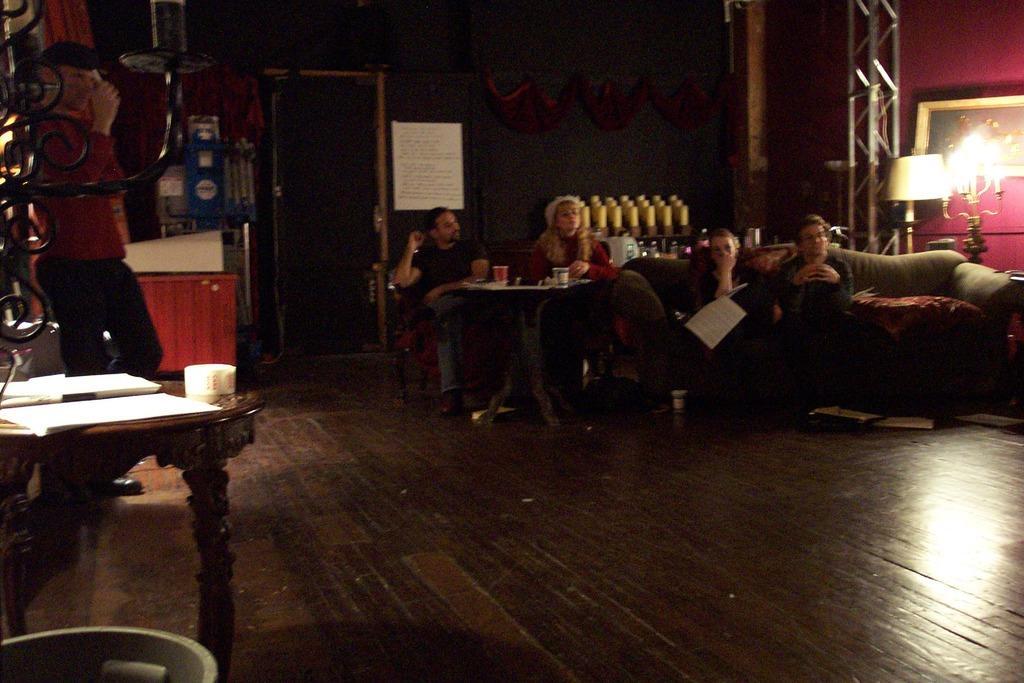Can you describe this image briefly? Here we can see a group of people sitting on a couch with table in front of them and cups of juices on it and at the right side we can see a lamp and at the left side we can see a man standing and at the center we can see a door 